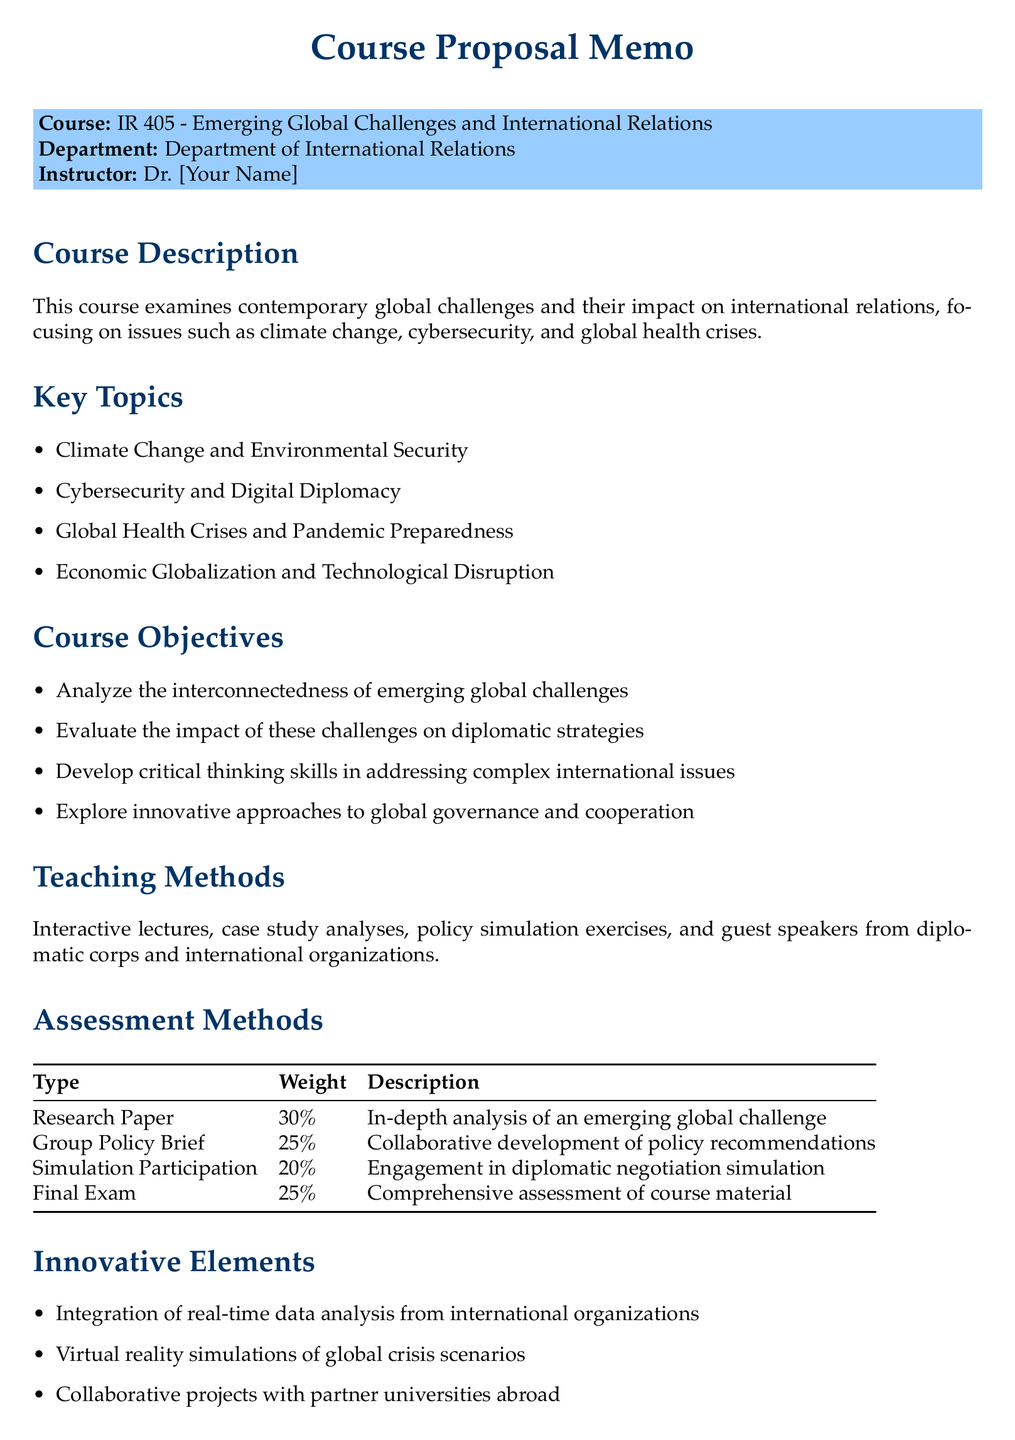What is the course title? The course title is stated at the beginning of the memo, which is about emerging global challenges.
Answer: Emerging Global Challenges and International Relations Who is the instructor? The instructor's name is mentioned under the course details section.
Answer: Dr. [Your Name] What is the weight of the research paper in the assessment methods? The weight of the research paper is specified in the table that lists the assessment methods.
Answer: 30% Which subtopic is associated with climate change? One of the subtopics listed under Climate Change and Environmental Security provides details on related issues.
Answer: Paris Agreement implementation challenges What is one innovative element introduced in the course? The document includes a section on innovative elements that highlights new approaches in the course.
Answer: Integration of real-time data analysis from international organizations What type of final assessment is included in the course? The final exam is listed as one of the assessment methods with specific details about its purpose.
Answer: Final Exam How many key topics are covered in the course? The key topics are enumerated in the document under specified sections.
Answer: Four What does the course aim to improve in students? The expected outcomes section of the memo outlines specific skills that the course intends to refine.
Answer: Analytical skills What is one of the course objectives? The course objectives are clearly outlined, indicating what students will achieve by the end of the course.
Answer: Develop critical thinking skills in addressing complex international issues 